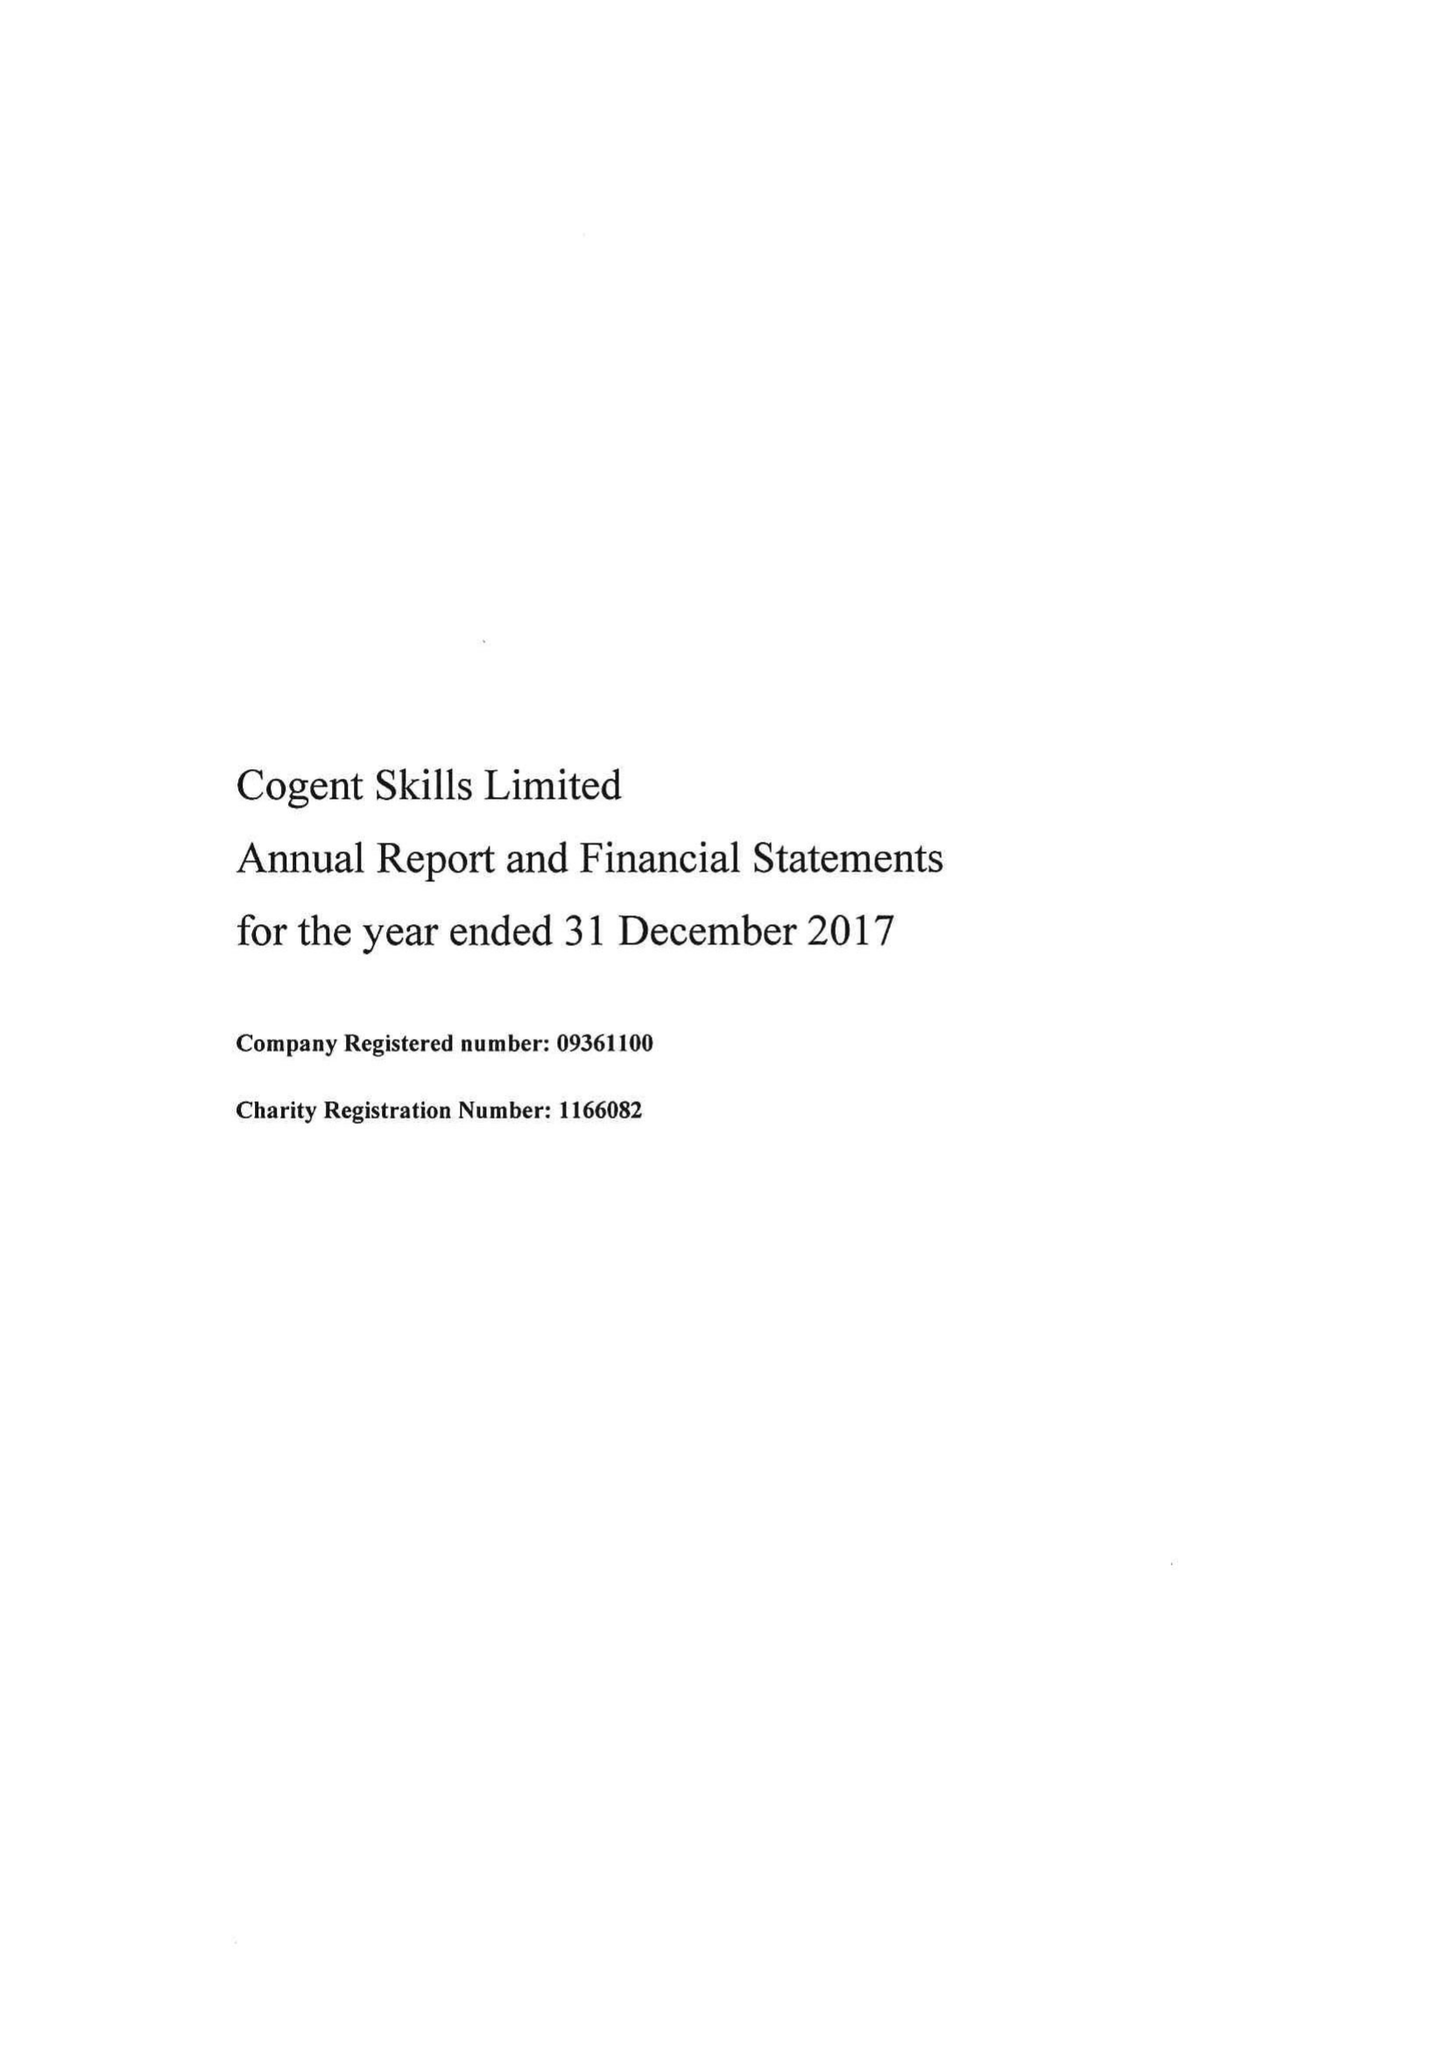What is the value for the address__street_line?
Answer the question using a single word or phrase. None 